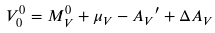<formula> <loc_0><loc_0><loc_500><loc_500>V _ { 0 } ^ { 0 } = M _ { V } ^ { 0 } + { \mu } _ { V } - { A _ { V } } ^ { \prime } + \Delta A _ { V }</formula> 